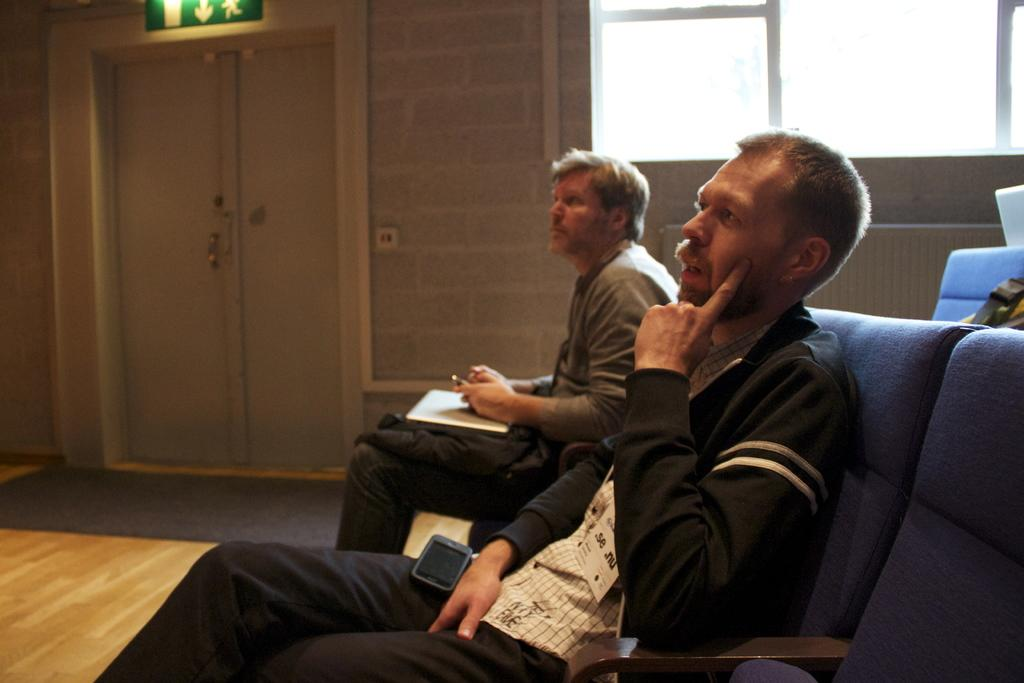How many people are seated in the image? There are two men seated in the image. What is one of the men holding in his hand? One man is holding a phone in his hand. Can you describe any other objects in the image? There is a visible mobile in the image. What type of sofa can be seen in the image? There is no sofa present in the image; it features two men seated on chairs. How many bubbles are floating around the men in the image? There are no bubbles present in the image. 